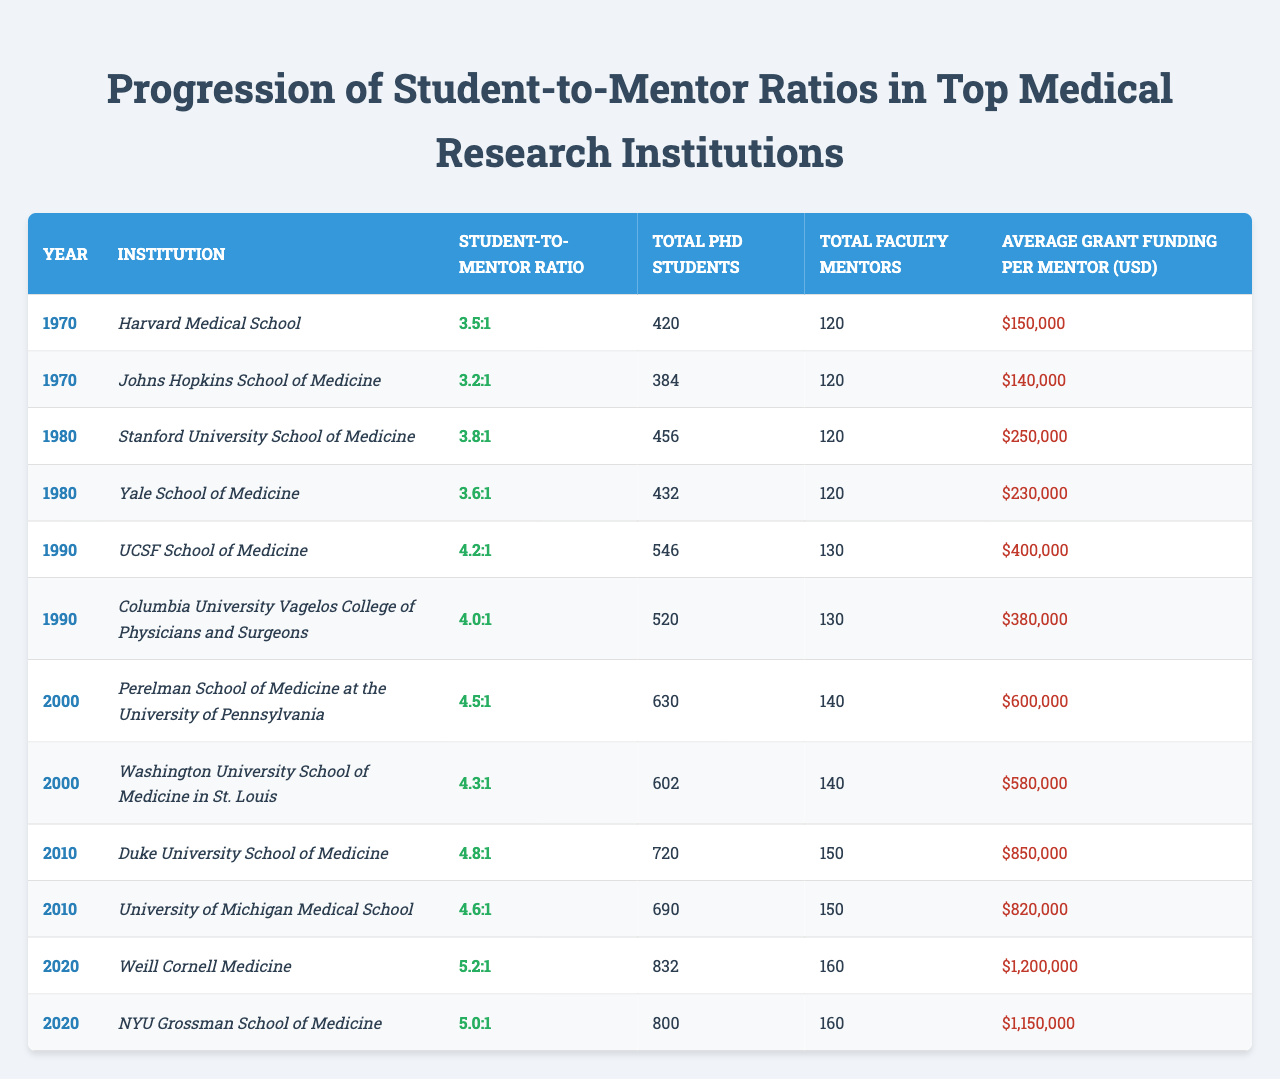What was the student-to-mentor ratio at Harvard Medical School in 1970? The table shows the student-to-mentor ratio for Harvard Medical School in 1970 as "3.5:1".
Answer: 3.5:1 Which institution had the highest student-to-mentor ratio in 2010? Referring to the table, Duke University School of Medicine had the highest student-to-mentor ratio of "4.8:1" in 2010.
Answer: Duke University School of Medicine How many total PhD students were there at Stanford University in 1980? According to the table, Stanford University School of Medicine had a total of 456 PhD students in 1980.
Answer: 456 Did the student-to-mentor ratio increase or decrease from 2000 to 2020 for Weill Cornell Medicine? In 2000, Weill Cornell Medicine does not appear in the data; however, in 2020 the ratio is "5.2:1". Since there is no previous ratio, we cannot compare.
Answer: N/A What is the average grant funding per mentor over the years provided in the table? To find the average, sum the grant funding amounts: 150000 + 140000 + 250000 + 230000 + 400000 + 380000 + 600000 + 580000 + 850000 + 820000 + 1200000 + 1150000 = 7,370,000. Then divide by the number of years (12), which gives approximately 614,167.
Answer: 614,167 How many total faculty mentors were there at UCSF School of Medicine in 1990? The table lists UCSF School of Medicine with a total of 130 faculty mentors in 1990.
Answer: 130 What was the increase in total PhD students from 1990 to 2000 at the University of Pennsylvania? The doctoral students in 1990 at the University of Pennsylvania were 546, and in 2000, it was 630. The difference is 630 - 546 = 84.
Answer: 84 Was the student-to-mentor ratio in 1980 higher than in 1990? In 1980, the ratio for Stanford was "3.8:1" and for Columbia was "4.0:1", while in 1990, UCSF had "4.2:1" and Columbia "4.0:1". Since UCSF's ratio is higher, the overall ratio in 1990 was higher than in 1980.
Answer: Yes What is the difference in average grant funding per mentor between 1980 and 2010? In 1980, the average grant funding per mentor was (250000 + 230000) / 2 = 240000 and in 2010 it was (850000 + 820000) / 2 = 835000. The difference is 835000 - 240000 = 595000.
Answer: 595000 Which institution consistently showed a less than 5.0:1 student-to-mentor ratio before 2010? Looking at all the data before 2010, both Harvard Medical School and Johns Hopkins School of Medicine had ratios below 5.0:1.
Answer: Harvard Medical School and Johns Hopkins School of Medicine What trend can be observed in student-to-mentor ratios over the last 50 years? The data indicates a consistent increase in the student-to-mentor ratios across the years, with the ratios moving from below 4.0:1 in the 1970s to above 5.0:1 in 2020.
Answer: Increasing trend 